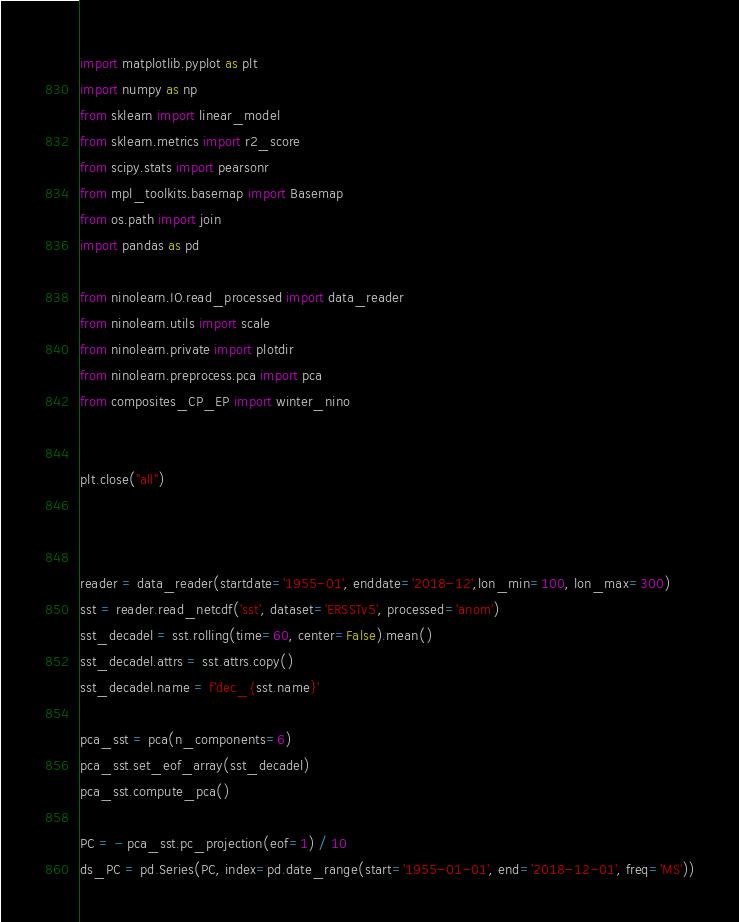<code> <loc_0><loc_0><loc_500><loc_500><_Python_>import matplotlib.pyplot as plt
import numpy as np
from sklearn import linear_model
from sklearn.metrics import r2_score
from scipy.stats import pearsonr
from mpl_toolkits.basemap import Basemap
from os.path import join
import pandas as pd

from ninolearn.IO.read_processed import data_reader
from ninolearn.utils import scale
from ninolearn.private import plotdir
from ninolearn.preprocess.pca import pca
from composites_CP_EP import winter_nino


plt.close("all")



reader = data_reader(startdate='1955-01', enddate='2018-12',lon_min=100, lon_max=300)
sst = reader.read_netcdf('sst', dataset='ERSSTv5', processed='anom')
sst_decadel = sst.rolling(time=60, center=False).mean()
sst_decadel.attrs = sst.attrs.copy()
sst_decadel.name = f'dec_{sst.name}'

pca_sst = pca(n_components=6)
pca_sst.set_eof_array(sst_decadel)
pca_sst.compute_pca()

PC = - pca_sst.pc_projection(eof=1) / 10
ds_PC = pd.Series(PC, index=pd.date_range(start='1955-01-01', end='2018-12-01', freq='MS'))


</code> 